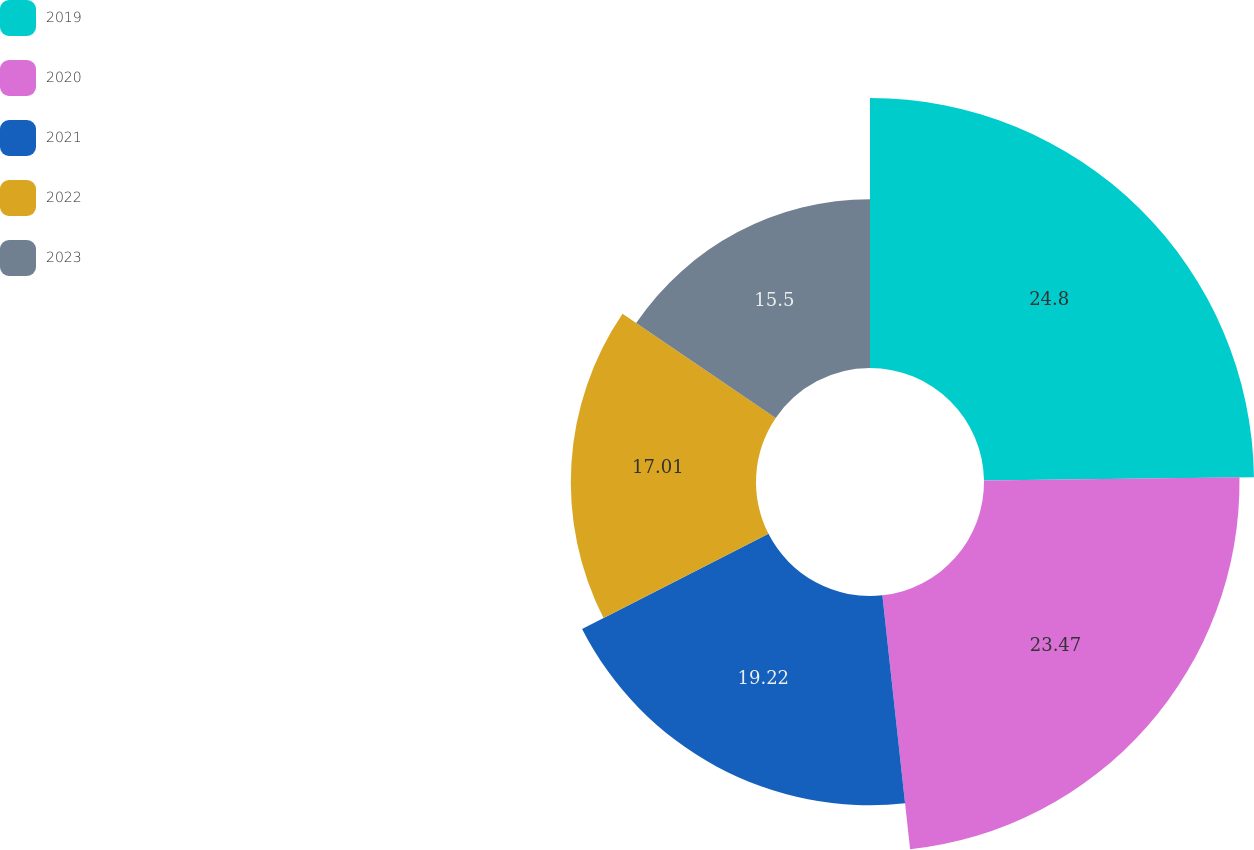Convert chart to OTSL. <chart><loc_0><loc_0><loc_500><loc_500><pie_chart><fcel>2019<fcel>2020<fcel>2021<fcel>2022<fcel>2023<nl><fcel>24.8%<fcel>23.47%<fcel>19.22%<fcel>17.01%<fcel>15.5%<nl></chart> 